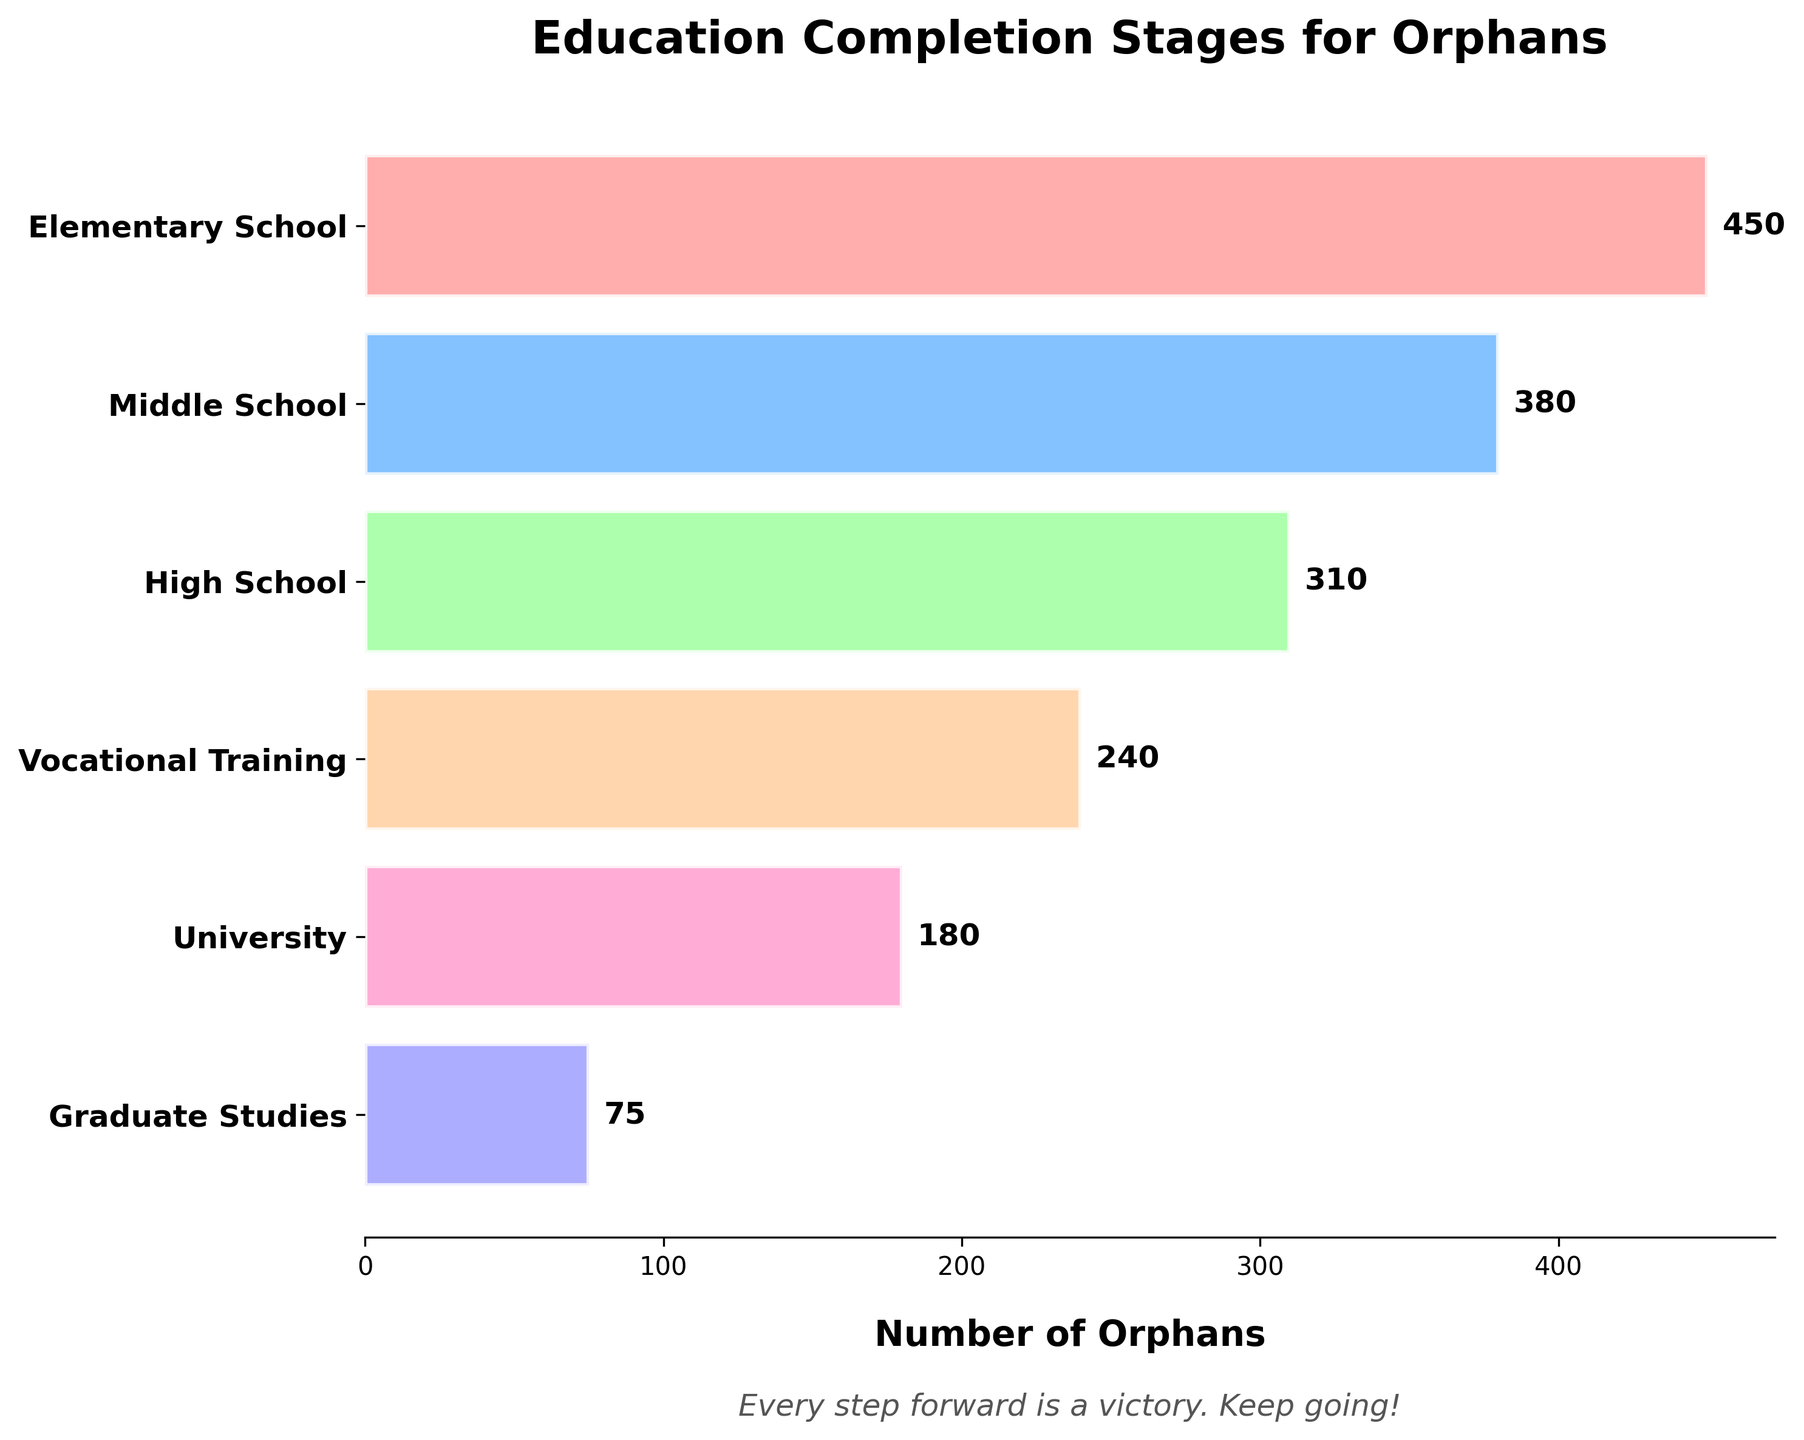How many stages of education completion are shown in the figure? Count the total number of different stages listed on the vertical axis of the funnel chart. There are six stages: Elementary School, Middle School, High School, Vocational Training, University, and Graduate Studies.
Answer: 6 Which stage has the highest number of orphans? Look at the funnel chart and identify the bar with the greatest length. The Elementary School stage has the longest bar.
Answer: Elementary School How many orphans have completed Middle School and High School combined? Add the number of orphans who have completed Middle School (380) to those who have completed High School (310). The sum is 380 + 310 = 690.
Answer: 690 What is the decrease in the number of orphans from Elementary School to University? Subtract the number of orphans who completed University (180) from those who completed Elementary School (450). The difference is 450 - 180 = 270.
Answer: 270 Which stage has fewer orphans, Vocational Training or Graduate Studies? Compare the lengths of the bars for Vocational Training (240) and Graduate Studies (75). Graduate Studies has fewer orphans.
Answer: Graduate Studies What is the average number of orphans per stage? Add the numbers of orphans for all six stages and then divide by the number of stages. (450 + 380 + 310 + 240 + 180 + 75) / 6 = 1635 / 6 ≈ 272.5
Answer: 272.5 Is the number of orphans in Graduate Studies more or less than half the number in Middle School? Calculate half of the number of orphans in Middle School (380 / 2 = 190) and compare it to the number in Graduate Studies (75). 75 is less than 190.
Answer: Less How does the number of orphans in High School compare to those in Vocational Training? Compare the numbers directly. High School has 310 orphans, and Vocational Training has 240 orphans. 310 is greater than 240.
Answer: High School has more What is the total number of orphans who completed any stage of the education program? Sum the numbers for all six stages. 450 + 380 + 310 + 240 + 180 + 75 = 1635.
Answer: 1635 